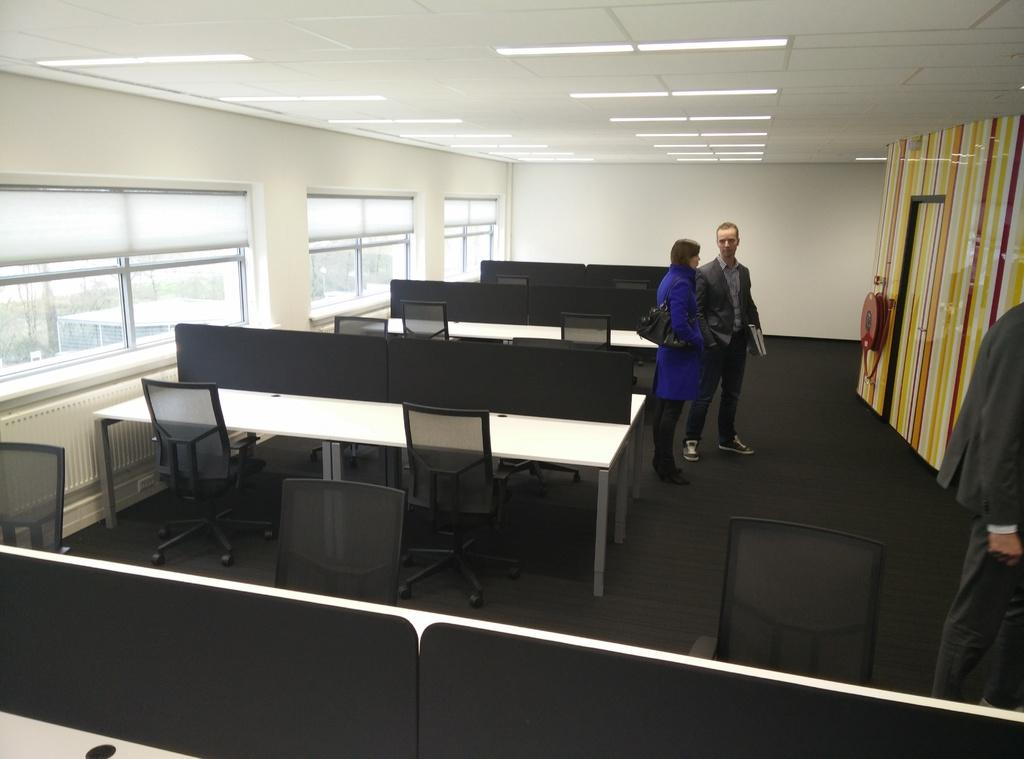What is located on the left side of the image? There are windows on the left side of the image. What type of furniture can be seen in the image? There are tables and chairs in the image. What are the people in the image doing? A woman and a man are standing in the middle of the image. What is the source of light in the image? There is a light at the top of the image. Can you see any marks made by a clam in the image? There is no mention of a clam or any marks made by it in the image. What type of wool is being used by the woman in the image? There is no indication of wool or any clothing item in the image. 